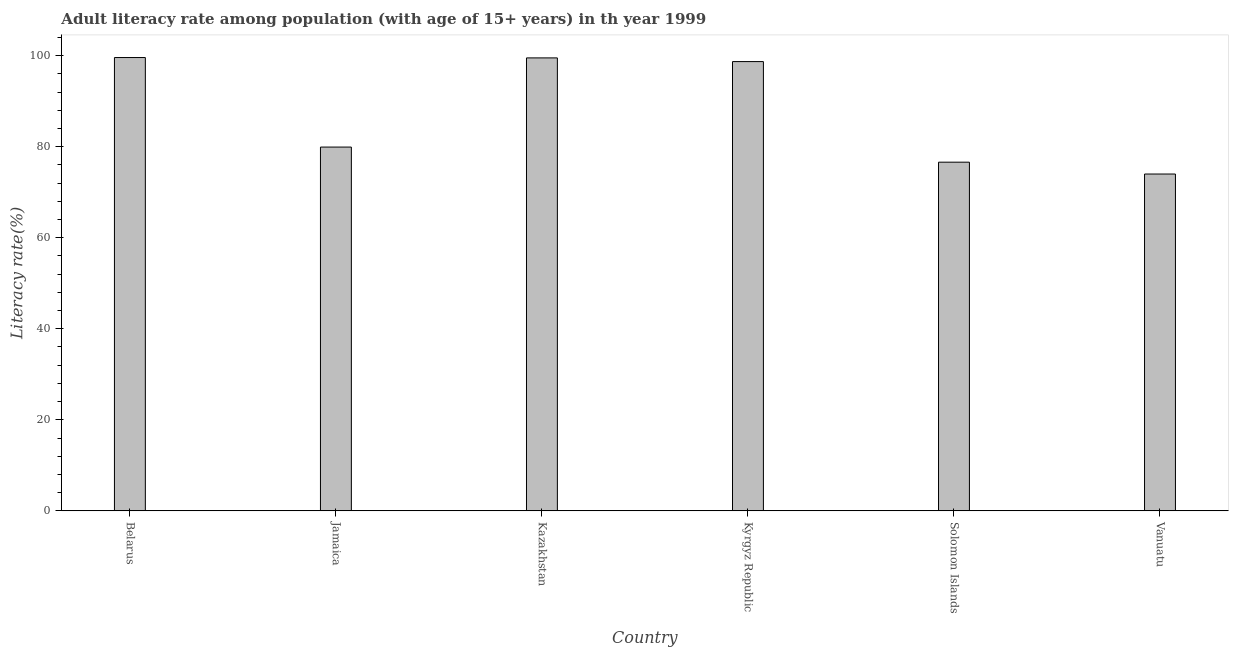Does the graph contain any zero values?
Your answer should be compact. No. What is the title of the graph?
Offer a very short reply. Adult literacy rate among population (with age of 15+ years) in th year 1999. What is the label or title of the Y-axis?
Your answer should be compact. Literacy rate(%). What is the adult literacy rate in Kyrgyz Republic?
Keep it short and to the point. 98.7. Across all countries, what is the maximum adult literacy rate?
Keep it short and to the point. 99.59. Across all countries, what is the minimum adult literacy rate?
Give a very brief answer. 74. In which country was the adult literacy rate maximum?
Ensure brevity in your answer.  Belarus. In which country was the adult literacy rate minimum?
Offer a very short reply. Vanuatu. What is the sum of the adult literacy rate?
Give a very brief answer. 528.33. What is the difference between the adult literacy rate in Belarus and Vanuatu?
Make the answer very short. 25.59. What is the average adult literacy rate per country?
Your response must be concise. 88.05. What is the median adult literacy rate?
Your answer should be compact. 89.31. What is the ratio of the adult literacy rate in Kazakhstan to that in Vanuatu?
Ensure brevity in your answer.  1.34. What is the difference between the highest and the second highest adult literacy rate?
Provide a succinct answer. 0.08. What is the difference between the highest and the lowest adult literacy rate?
Offer a very short reply. 25.59. In how many countries, is the adult literacy rate greater than the average adult literacy rate taken over all countries?
Your answer should be compact. 3. What is the difference between two consecutive major ticks on the Y-axis?
Provide a short and direct response. 20. What is the Literacy rate(%) of Belarus?
Your answer should be compact. 99.59. What is the Literacy rate(%) of Jamaica?
Provide a short and direct response. 79.92. What is the Literacy rate(%) of Kazakhstan?
Your answer should be very brief. 99.51. What is the Literacy rate(%) in Kyrgyz Republic?
Provide a short and direct response. 98.7. What is the Literacy rate(%) of Solomon Islands?
Provide a short and direct response. 76.6. What is the Literacy rate(%) of Vanuatu?
Your response must be concise. 74. What is the difference between the Literacy rate(%) in Belarus and Jamaica?
Your answer should be compact. 19.67. What is the difference between the Literacy rate(%) in Belarus and Kazakhstan?
Offer a very short reply. 0.08. What is the difference between the Literacy rate(%) in Belarus and Kyrgyz Republic?
Keep it short and to the point. 0.89. What is the difference between the Literacy rate(%) in Belarus and Solomon Islands?
Give a very brief answer. 22.99. What is the difference between the Literacy rate(%) in Belarus and Vanuatu?
Your answer should be compact. 25.59. What is the difference between the Literacy rate(%) in Jamaica and Kazakhstan?
Give a very brief answer. -19.59. What is the difference between the Literacy rate(%) in Jamaica and Kyrgyz Republic?
Provide a succinct answer. -18.78. What is the difference between the Literacy rate(%) in Jamaica and Solomon Islands?
Your answer should be very brief. 3.32. What is the difference between the Literacy rate(%) in Jamaica and Vanuatu?
Your response must be concise. 5.92. What is the difference between the Literacy rate(%) in Kazakhstan and Kyrgyz Republic?
Provide a succinct answer. 0.81. What is the difference between the Literacy rate(%) in Kazakhstan and Solomon Islands?
Your answer should be compact. 22.91. What is the difference between the Literacy rate(%) in Kazakhstan and Vanuatu?
Your response must be concise. 25.51. What is the difference between the Literacy rate(%) in Kyrgyz Republic and Solomon Islands?
Your response must be concise. 22.1. What is the difference between the Literacy rate(%) in Kyrgyz Republic and Vanuatu?
Your answer should be compact. 24.7. What is the difference between the Literacy rate(%) in Solomon Islands and Vanuatu?
Give a very brief answer. 2.6. What is the ratio of the Literacy rate(%) in Belarus to that in Jamaica?
Provide a succinct answer. 1.25. What is the ratio of the Literacy rate(%) in Belarus to that in Kazakhstan?
Ensure brevity in your answer.  1. What is the ratio of the Literacy rate(%) in Belarus to that in Vanuatu?
Offer a very short reply. 1.35. What is the ratio of the Literacy rate(%) in Jamaica to that in Kazakhstan?
Offer a terse response. 0.8. What is the ratio of the Literacy rate(%) in Jamaica to that in Kyrgyz Republic?
Your answer should be very brief. 0.81. What is the ratio of the Literacy rate(%) in Jamaica to that in Solomon Islands?
Offer a terse response. 1.04. What is the ratio of the Literacy rate(%) in Jamaica to that in Vanuatu?
Ensure brevity in your answer.  1.08. What is the ratio of the Literacy rate(%) in Kazakhstan to that in Solomon Islands?
Offer a terse response. 1.3. What is the ratio of the Literacy rate(%) in Kazakhstan to that in Vanuatu?
Keep it short and to the point. 1.34. What is the ratio of the Literacy rate(%) in Kyrgyz Republic to that in Solomon Islands?
Your answer should be compact. 1.29. What is the ratio of the Literacy rate(%) in Kyrgyz Republic to that in Vanuatu?
Give a very brief answer. 1.33. What is the ratio of the Literacy rate(%) in Solomon Islands to that in Vanuatu?
Give a very brief answer. 1.03. 